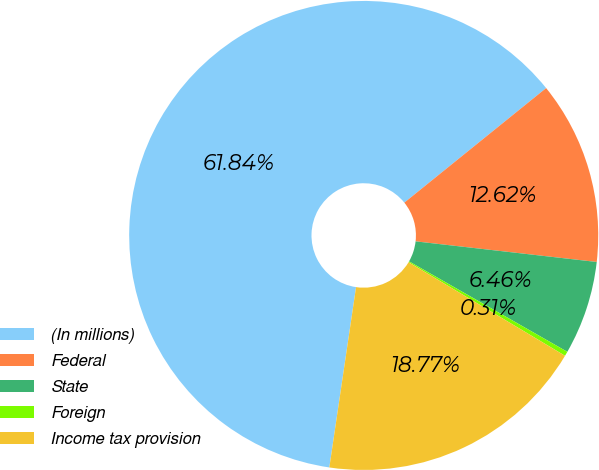Convert chart to OTSL. <chart><loc_0><loc_0><loc_500><loc_500><pie_chart><fcel>(In millions)<fcel>Federal<fcel>State<fcel>Foreign<fcel>Income tax provision<nl><fcel>61.85%<fcel>12.62%<fcel>6.46%<fcel>0.31%<fcel>18.77%<nl></chart> 